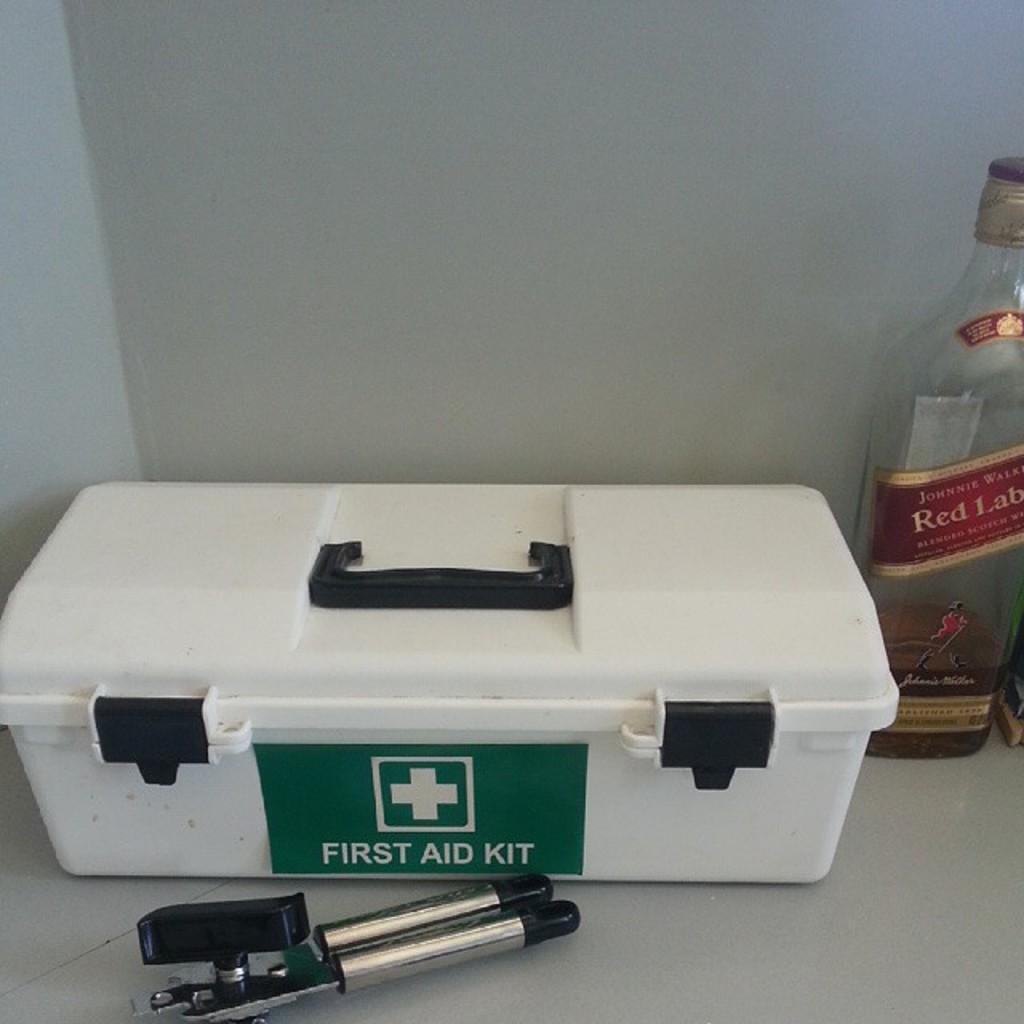Can you describe this image briefly? In this image there is a white color box and at the right there is a bottle, in the front there is a tool. 